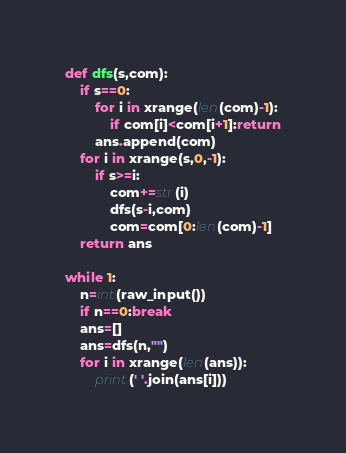<code> <loc_0><loc_0><loc_500><loc_500><_Python_>def dfs(s,com):
    if s==0:
        for i in xrange(len(com)-1):
            if com[i]<com[i+1]:return
        ans.append(com)
    for i in xrange(s,0,-1):
        if s>=i:
            com+=str(i)
            dfs(s-i,com)
            com=com[0:len(com)-1]
    return ans

while 1:
    n=int(raw_input())
    if n==0:break
    ans=[]
    ans=dfs(n,"")
    for i in xrange(len(ans)):
        print(' '.join(ans[i]))</code> 